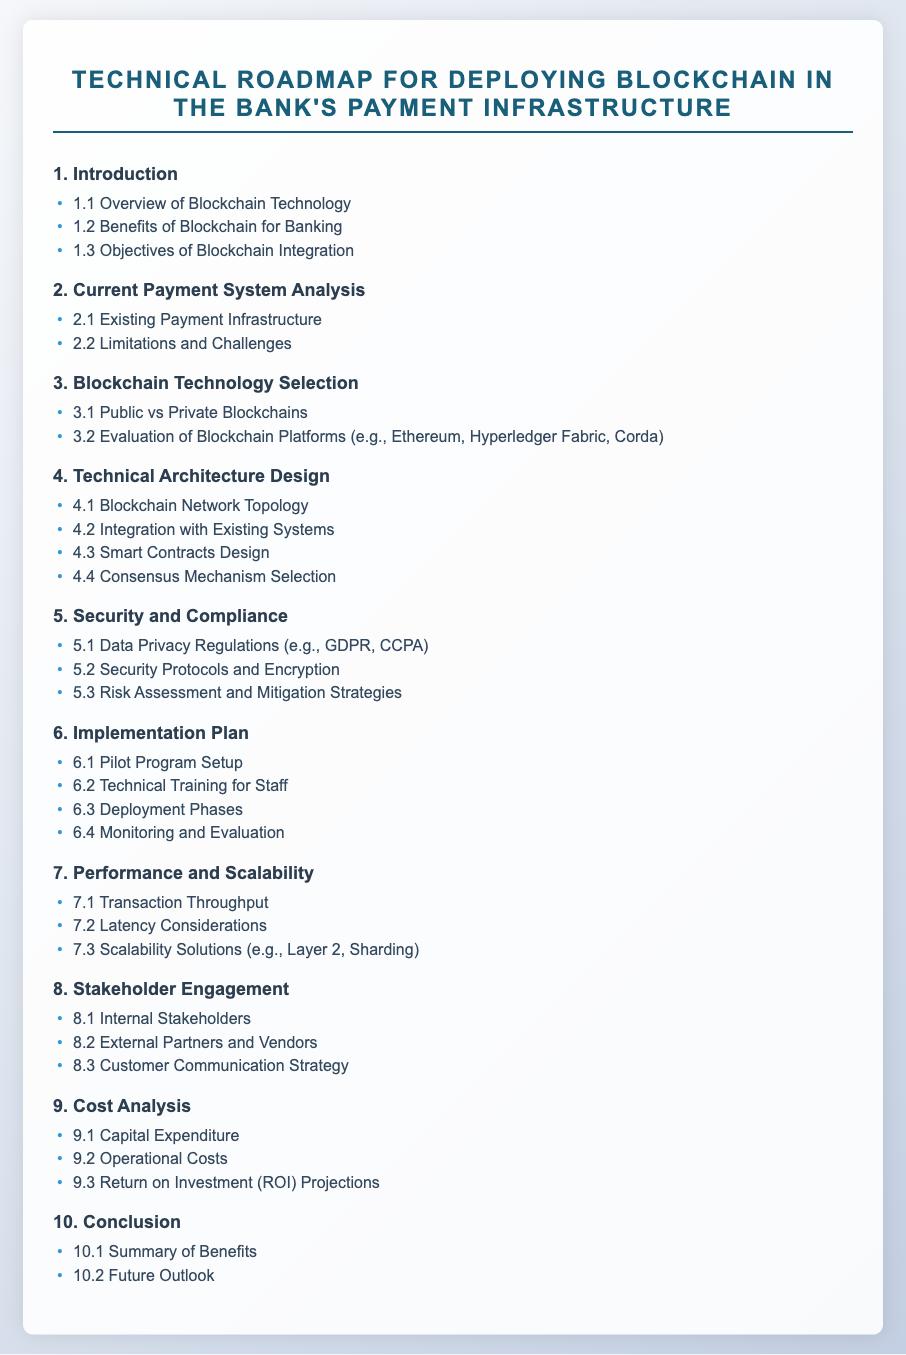What is the main title of the document? The main title of the document is located at the top of the rendered page and describes the purpose of the document.
Answer: Technical Roadmap for Deploying Blockchain in the Bank's Payment Infrastructure How many sections are in the document? The document's content is organized into distinct sections, which can be counted from the outline provided.
Answer: 10 What is one benefit of blockchain for banking? The document lists benefits in a subsection dedicated to benefits, highlighting its significance for the banking sector.
Answer: Increased efficiency What type of blockchains are evaluated in the blockchain technology selection section? This inquiry seeks to identify the types of blockchains mentioned, which are crucial for the evaluation process.
Answer: Public vs Private Blockchains What does the security and compliance section address? This question targets the focus of the section, highlighting key elements that need to be considered for implementation.
Answer: Data Privacy Regulations What is included in the cost analysis section? This question investigates the components being analyzed regarding the costs involved, reflecting on financial implications.
Answer: Capital Expenditure What are the two categories of stakeholders mentioned? The document outlines different stakeholder groups involved in the process, which are essential for engagement strategies.
Answer: Internal and External Stakeholders What is the final section of the document called? This question focuses on the last part of the document, referring to its purpose and content concerning blockchain integration.
Answer: Conclusion What is one solution discussed for scalability? The document explores solutions to address scalability challenges, which are vital for the successful deployment of blockchain networks.
Answer: Layer 2 What aspect does the implementation plan focus on? This question looks for the specific focus area of the implementation plan, highlighting its role in the deployment process.
Answer: Pilot Program Setup 